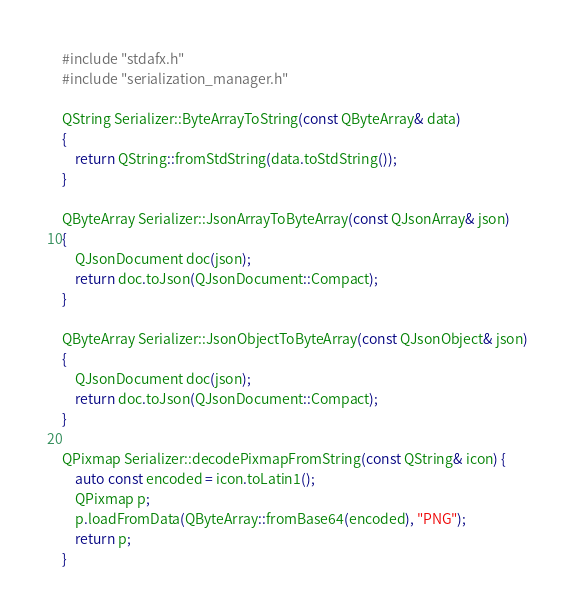Convert code to text. <code><loc_0><loc_0><loc_500><loc_500><_C++_>#include "stdafx.h"
#include "serialization_manager.h"

QString Serializer::ByteArrayToString(const QByteArray& data)
{
	return QString::fromStdString(data.toStdString());
}

QByteArray Serializer::JsonArrayToByteArray(const QJsonArray& json)
{
	QJsonDocument doc(json);
	return doc.toJson(QJsonDocument::Compact);
}

QByteArray Serializer::JsonObjectToByteArray(const QJsonObject& json)
{
	QJsonDocument doc(json);
	return doc.toJson(QJsonDocument::Compact);
}

QPixmap Serializer::decodePixmapFromString(const QString& icon) {
	auto const encoded = icon.toLatin1();
	QPixmap p;
	p.loadFromData(QByteArray::fromBase64(encoded), "PNG");
	return p;
}</code> 